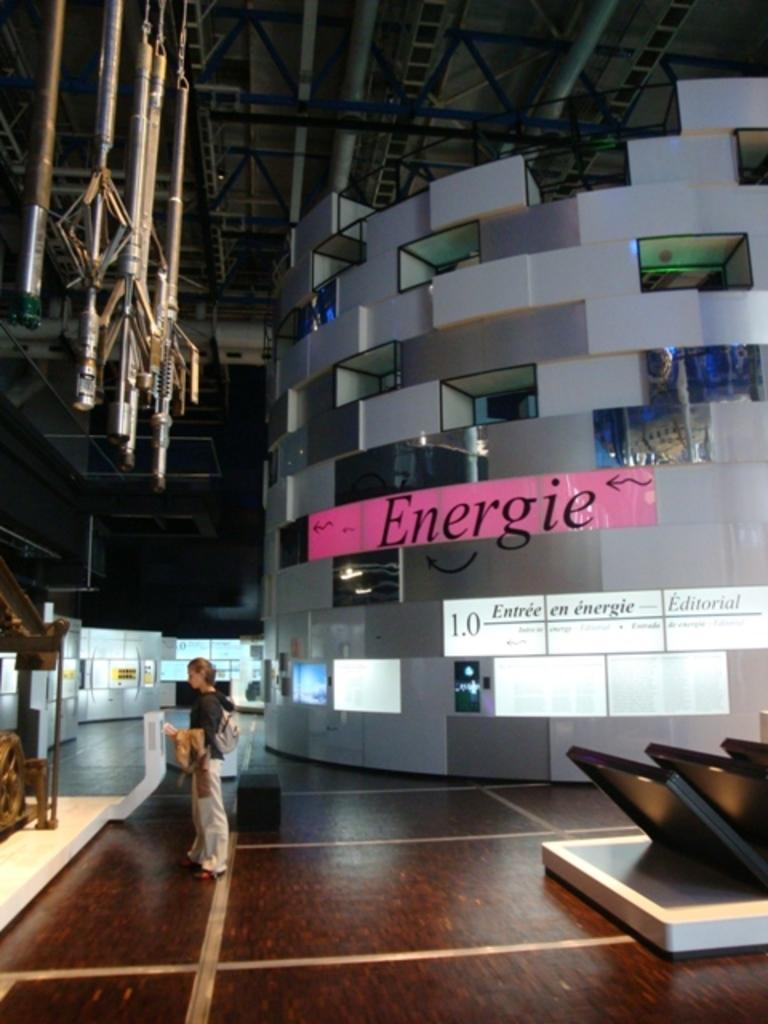<image>
Offer a succinct explanation of the picture presented. A woman standing in a large open building with a poster labeled "Energie" above her. 